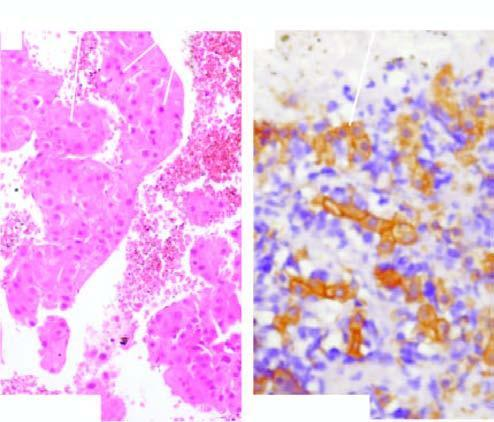re various types of epithelial cells stain with cytokeratin for epithelial cells?
Answer the question using a single word or phrase. No 